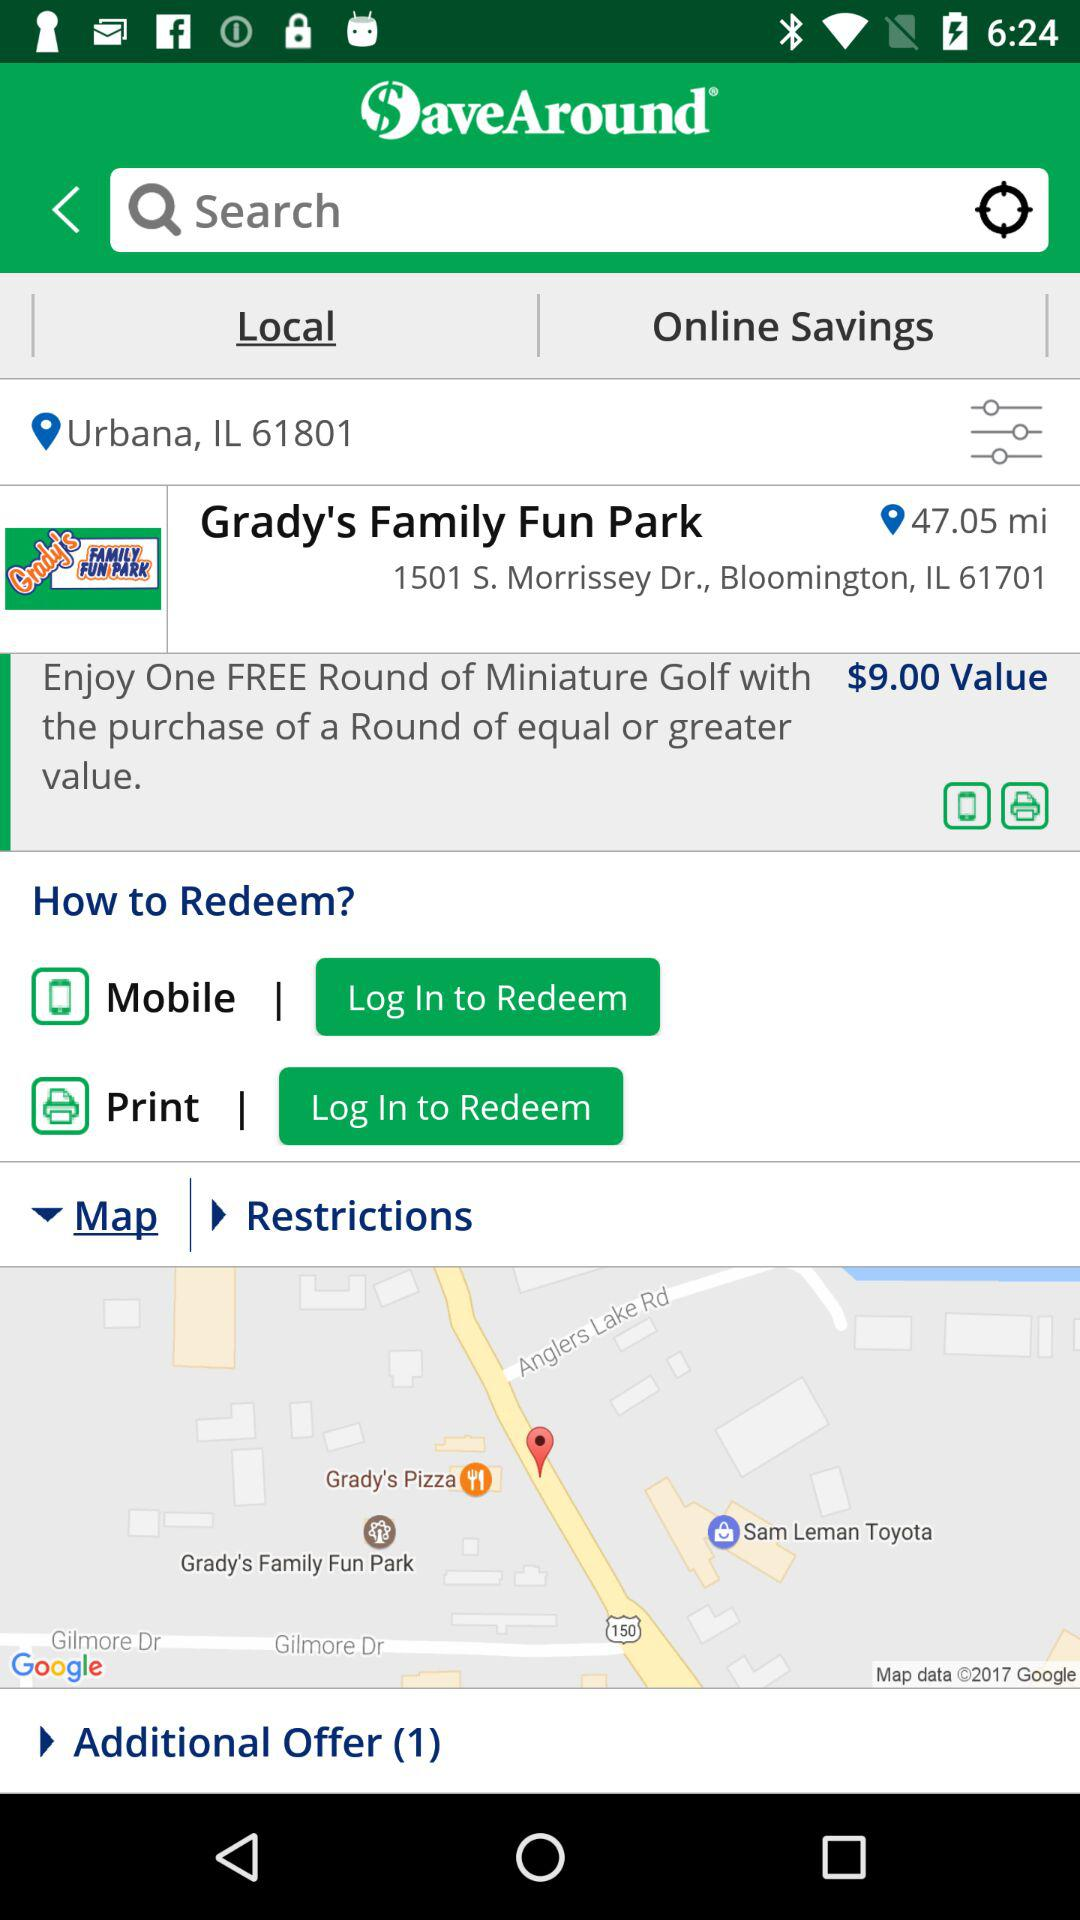What is the price for the purchase of a round of "Miniature Golf"? The price is $9. 